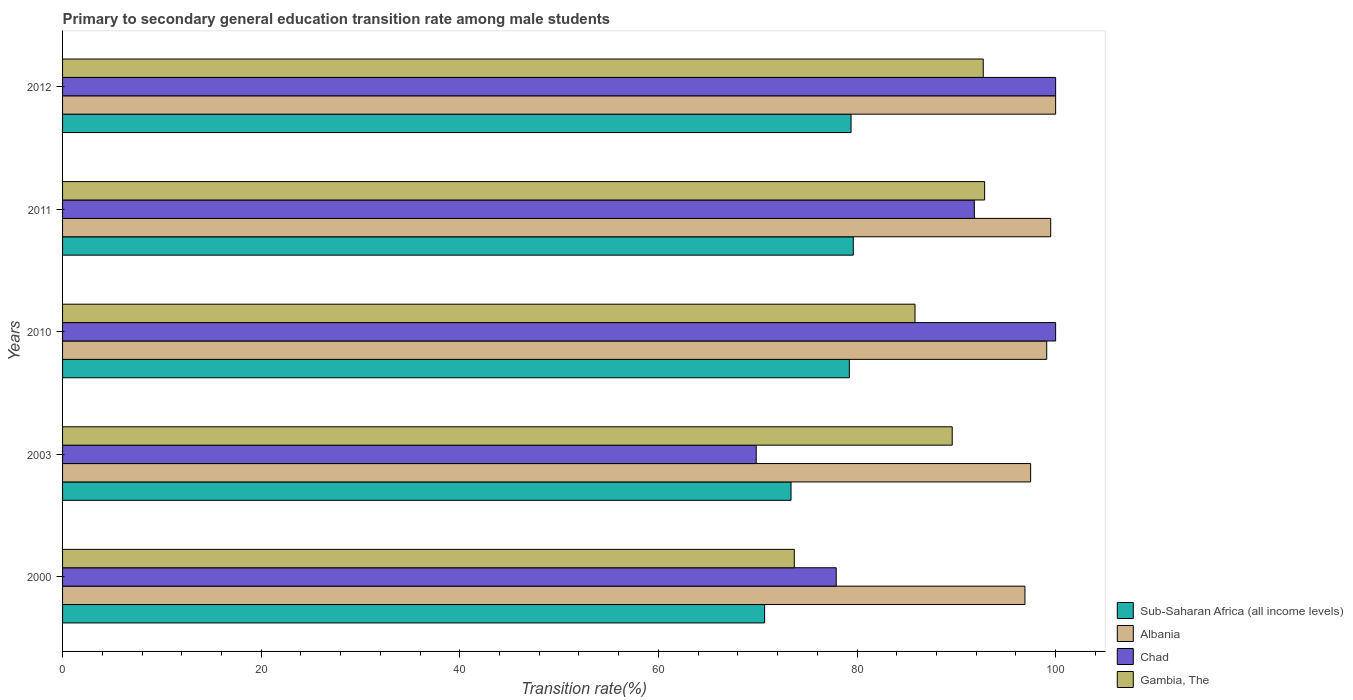Are the number of bars per tick equal to the number of legend labels?
Your answer should be very brief. Yes. How many bars are there on the 3rd tick from the top?
Offer a terse response. 4. In how many cases, is the number of bars for a given year not equal to the number of legend labels?
Offer a terse response. 0. What is the transition rate in Sub-Saharan Africa (all income levels) in 2012?
Offer a very short reply. 79.4. Across all years, what is the maximum transition rate in Gambia, The?
Provide a succinct answer. 92.85. Across all years, what is the minimum transition rate in Albania?
Your response must be concise. 96.91. In which year was the transition rate in Albania maximum?
Make the answer very short. 2012. In which year was the transition rate in Albania minimum?
Keep it short and to the point. 2000. What is the total transition rate in Sub-Saharan Africa (all income levels) in the graph?
Offer a terse response. 382.31. What is the difference between the transition rate in Chad in 2003 and that in 2012?
Offer a terse response. -30.15. What is the difference between the transition rate in Albania in 2000 and the transition rate in Sub-Saharan Africa (all income levels) in 2012?
Provide a succinct answer. 17.51. What is the average transition rate in Albania per year?
Your answer should be compact. 98.6. In the year 2003, what is the difference between the transition rate in Sub-Saharan Africa (all income levels) and transition rate in Albania?
Provide a succinct answer. -24.13. What is the ratio of the transition rate in Albania in 2011 to that in 2012?
Ensure brevity in your answer.  1. What is the difference between the highest and the lowest transition rate in Chad?
Ensure brevity in your answer.  30.15. In how many years, is the transition rate in Gambia, The greater than the average transition rate in Gambia, The taken over all years?
Keep it short and to the point. 3. Is the sum of the transition rate in Albania in 2003 and 2012 greater than the maximum transition rate in Chad across all years?
Your response must be concise. Yes. Is it the case that in every year, the sum of the transition rate in Gambia, The and transition rate in Chad is greater than the sum of transition rate in Sub-Saharan Africa (all income levels) and transition rate in Albania?
Your response must be concise. No. What does the 2nd bar from the top in 2000 represents?
Make the answer very short. Chad. What does the 3rd bar from the bottom in 2003 represents?
Your answer should be very brief. Chad. How many years are there in the graph?
Give a very brief answer. 5. Where does the legend appear in the graph?
Give a very brief answer. Bottom right. What is the title of the graph?
Offer a terse response. Primary to secondary general education transition rate among male students. Does "Moldova" appear as one of the legend labels in the graph?
Provide a short and direct response. No. What is the label or title of the X-axis?
Give a very brief answer. Transition rate(%). What is the label or title of the Y-axis?
Your response must be concise. Years. What is the Transition rate(%) of Sub-Saharan Africa (all income levels) in 2000?
Ensure brevity in your answer.  70.7. What is the Transition rate(%) of Albania in 2000?
Your response must be concise. 96.91. What is the Transition rate(%) of Chad in 2000?
Your response must be concise. 77.91. What is the Transition rate(%) of Gambia, The in 2000?
Your answer should be very brief. 73.69. What is the Transition rate(%) of Sub-Saharan Africa (all income levels) in 2003?
Your response must be concise. 73.36. What is the Transition rate(%) in Albania in 2003?
Make the answer very short. 97.48. What is the Transition rate(%) of Chad in 2003?
Ensure brevity in your answer.  69.85. What is the Transition rate(%) of Gambia, The in 2003?
Offer a very short reply. 89.59. What is the Transition rate(%) of Sub-Saharan Africa (all income levels) in 2010?
Offer a very short reply. 79.23. What is the Transition rate(%) of Albania in 2010?
Offer a terse response. 99.1. What is the Transition rate(%) in Chad in 2010?
Make the answer very short. 100. What is the Transition rate(%) in Gambia, The in 2010?
Your answer should be compact. 85.84. What is the Transition rate(%) of Sub-Saharan Africa (all income levels) in 2011?
Provide a succinct answer. 79.62. What is the Transition rate(%) in Albania in 2011?
Ensure brevity in your answer.  99.5. What is the Transition rate(%) of Chad in 2011?
Give a very brief answer. 91.82. What is the Transition rate(%) in Gambia, The in 2011?
Your response must be concise. 92.85. What is the Transition rate(%) in Sub-Saharan Africa (all income levels) in 2012?
Keep it short and to the point. 79.4. What is the Transition rate(%) in Gambia, The in 2012?
Offer a very short reply. 92.71. Across all years, what is the maximum Transition rate(%) of Sub-Saharan Africa (all income levels)?
Ensure brevity in your answer.  79.62. Across all years, what is the maximum Transition rate(%) of Gambia, The?
Your answer should be very brief. 92.85. Across all years, what is the minimum Transition rate(%) of Sub-Saharan Africa (all income levels)?
Make the answer very short. 70.7. Across all years, what is the minimum Transition rate(%) in Albania?
Ensure brevity in your answer.  96.91. Across all years, what is the minimum Transition rate(%) in Chad?
Offer a terse response. 69.85. Across all years, what is the minimum Transition rate(%) in Gambia, The?
Offer a very short reply. 73.69. What is the total Transition rate(%) in Sub-Saharan Africa (all income levels) in the graph?
Give a very brief answer. 382.31. What is the total Transition rate(%) in Albania in the graph?
Offer a terse response. 493. What is the total Transition rate(%) of Chad in the graph?
Provide a short and direct response. 439.57. What is the total Transition rate(%) of Gambia, The in the graph?
Give a very brief answer. 434.68. What is the difference between the Transition rate(%) of Sub-Saharan Africa (all income levels) in 2000 and that in 2003?
Provide a short and direct response. -2.66. What is the difference between the Transition rate(%) of Albania in 2000 and that in 2003?
Provide a short and direct response. -0.57. What is the difference between the Transition rate(%) in Chad in 2000 and that in 2003?
Offer a terse response. 8.06. What is the difference between the Transition rate(%) of Gambia, The in 2000 and that in 2003?
Make the answer very short. -15.9. What is the difference between the Transition rate(%) of Sub-Saharan Africa (all income levels) in 2000 and that in 2010?
Provide a short and direct response. -8.53. What is the difference between the Transition rate(%) of Albania in 2000 and that in 2010?
Offer a terse response. -2.19. What is the difference between the Transition rate(%) of Chad in 2000 and that in 2010?
Your response must be concise. -22.09. What is the difference between the Transition rate(%) in Gambia, The in 2000 and that in 2010?
Ensure brevity in your answer.  -12.15. What is the difference between the Transition rate(%) in Sub-Saharan Africa (all income levels) in 2000 and that in 2011?
Your answer should be very brief. -8.93. What is the difference between the Transition rate(%) of Albania in 2000 and that in 2011?
Ensure brevity in your answer.  -2.6. What is the difference between the Transition rate(%) in Chad in 2000 and that in 2011?
Keep it short and to the point. -13.91. What is the difference between the Transition rate(%) in Gambia, The in 2000 and that in 2011?
Provide a short and direct response. -19.17. What is the difference between the Transition rate(%) in Sub-Saharan Africa (all income levels) in 2000 and that in 2012?
Your answer should be compact. -8.7. What is the difference between the Transition rate(%) in Albania in 2000 and that in 2012?
Your answer should be very brief. -3.09. What is the difference between the Transition rate(%) of Chad in 2000 and that in 2012?
Give a very brief answer. -22.09. What is the difference between the Transition rate(%) in Gambia, The in 2000 and that in 2012?
Your answer should be compact. -19.03. What is the difference between the Transition rate(%) of Sub-Saharan Africa (all income levels) in 2003 and that in 2010?
Offer a terse response. -5.87. What is the difference between the Transition rate(%) in Albania in 2003 and that in 2010?
Keep it short and to the point. -1.62. What is the difference between the Transition rate(%) in Chad in 2003 and that in 2010?
Provide a short and direct response. -30.15. What is the difference between the Transition rate(%) in Gambia, The in 2003 and that in 2010?
Your answer should be compact. 3.75. What is the difference between the Transition rate(%) in Sub-Saharan Africa (all income levels) in 2003 and that in 2011?
Provide a short and direct response. -6.27. What is the difference between the Transition rate(%) in Albania in 2003 and that in 2011?
Provide a short and direct response. -2.02. What is the difference between the Transition rate(%) in Chad in 2003 and that in 2011?
Offer a very short reply. -21.97. What is the difference between the Transition rate(%) of Gambia, The in 2003 and that in 2011?
Make the answer very short. -3.26. What is the difference between the Transition rate(%) in Sub-Saharan Africa (all income levels) in 2003 and that in 2012?
Offer a terse response. -6.04. What is the difference between the Transition rate(%) of Albania in 2003 and that in 2012?
Give a very brief answer. -2.52. What is the difference between the Transition rate(%) in Chad in 2003 and that in 2012?
Ensure brevity in your answer.  -30.15. What is the difference between the Transition rate(%) in Gambia, The in 2003 and that in 2012?
Offer a terse response. -3.12. What is the difference between the Transition rate(%) in Sub-Saharan Africa (all income levels) in 2010 and that in 2011?
Provide a short and direct response. -0.39. What is the difference between the Transition rate(%) of Albania in 2010 and that in 2011?
Your response must be concise. -0.4. What is the difference between the Transition rate(%) in Chad in 2010 and that in 2011?
Offer a terse response. 8.18. What is the difference between the Transition rate(%) of Gambia, The in 2010 and that in 2011?
Your answer should be compact. -7.01. What is the difference between the Transition rate(%) in Sub-Saharan Africa (all income levels) in 2010 and that in 2012?
Ensure brevity in your answer.  -0.17. What is the difference between the Transition rate(%) of Albania in 2010 and that in 2012?
Give a very brief answer. -0.9. What is the difference between the Transition rate(%) of Chad in 2010 and that in 2012?
Your response must be concise. 0. What is the difference between the Transition rate(%) in Gambia, The in 2010 and that in 2012?
Ensure brevity in your answer.  -6.87. What is the difference between the Transition rate(%) of Sub-Saharan Africa (all income levels) in 2011 and that in 2012?
Make the answer very short. 0.23. What is the difference between the Transition rate(%) of Albania in 2011 and that in 2012?
Ensure brevity in your answer.  -0.5. What is the difference between the Transition rate(%) in Chad in 2011 and that in 2012?
Give a very brief answer. -8.18. What is the difference between the Transition rate(%) in Gambia, The in 2011 and that in 2012?
Offer a terse response. 0.14. What is the difference between the Transition rate(%) of Sub-Saharan Africa (all income levels) in 2000 and the Transition rate(%) of Albania in 2003?
Provide a short and direct response. -26.79. What is the difference between the Transition rate(%) of Sub-Saharan Africa (all income levels) in 2000 and the Transition rate(%) of Chad in 2003?
Your answer should be compact. 0.85. What is the difference between the Transition rate(%) of Sub-Saharan Africa (all income levels) in 2000 and the Transition rate(%) of Gambia, The in 2003?
Offer a terse response. -18.89. What is the difference between the Transition rate(%) in Albania in 2000 and the Transition rate(%) in Chad in 2003?
Keep it short and to the point. 27.06. What is the difference between the Transition rate(%) of Albania in 2000 and the Transition rate(%) of Gambia, The in 2003?
Provide a succinct answer. 7.32. What is the difference between the Transition rate(%) of Chad in 2000 and the Transition rate(%) of Gambia, The in 2003?
Ensure brevity in your answer.  -11.68. What is the difference between the Transition rate(%) of Sub-Saharan Africa (all income levels) in 2000 and the Transition rate(%) of Albania in 2010?
Offer a very short reply. -28.41. What is the difference between the Transition rate(%) of Sub-Saharan Africa (all income levels) in 2000 and the Transition rate(%) of Chad in 2010?
Your response must be concise. -29.3. What is the difference between the Transition rate(%) in Sub-Saharan Africa (all income levels) in 2000 and the Transition rate(%) in Gambia, The in 2010?
Your answer should be compact. -15.14. What is the difference between the Transition rate(%) of Albania in 2000 and the Transition rate(%) of Chad in 2010?
Your answer should be very brief. -3.09. What is the difference between the Transition rate(%) in Albania in 2000 and the Transition rate(%) in Gambia, The in 2010?
Ensure brevity in your answer.  11.07. What is the difference between the Transition rate(%) in Chad in 2000 and the Transition rate(%) in Gambia, The in 2010?
Keep it short and to the point. -7.94. What is the difference between the Transition rate(%) in Sub-Saharan Africa (all income levels) in 2000 and the Transition rate(%) in Albania in 2011?
Provide a succinct answer. -28.81. What is the difference between the Transition rate(%) of Sub-Saharan Africa (all income levels) in 2000 and the Transition rate(%) of Chad in 2011?
Your answer should be very brief. -21.12. What is the difference between the Transition rate(%) in Sub-Saharan Africa (all income levels) in 2000 and the Transition rate(%) in Gambia, The in 2011?
Ensure brevity in your answer.  -22.16. What is the difference between the Transition rate(%) in Albania in 2000 and the Transition rate(%) in Chad in 2011?
Your answer should be very brief. 5.09. What is the difference between the Transition rate(%) of Albania in 2000 and the Transition rate(%) of Gambia, The in 2011?
Offer a terse response. 4.06. What is the difference between the Transition rate(%) of Chad in 2000 and the Transition rate(%) of Gambia, The in 2011?
Offer a very short reply. -14.95. What is the difference between the Transition rate(%) of Sub-Saharan Africa (all income levels) in 2000 and the Transition rate(%) of Albania in 2012?
Offer a terse response. -29.3. What is the difference between the Transition rate(%) in Sub-Saharan Africa (all income levels) in 2000 and the Transition rate(%) in Chad in 2012?
Offer a terse response. -29.3. What is the difference between the Transition rate(%) of Sub-Saharan Africa (all income levels) in 2000 and the Transition rate(%) of Gambia, The in 2012?
Ensure brevity in your answer.  -22.02. What is the difference between the Transition rate(%) of Albania in 2000 and the Transition rate(%) of Chad in 2012?
Offer a very short reply. -3.09. What is the difference between the Transition rate(%) of Albania in 2000 and the Transition rate(%) of Gambia, The in 2012?
Your response must be concise. 4.2. What is the difference between the Transition rate(%) in Chad in 2000 and the Transition rate(%) in Gambia, The in 2012?
Ensure brevity in your answer.  -14.81. What is the difference between the Transition rate(%) in Sub-Saharan Africa (all income levels) in 2003 and the Transition rate(%) in Albania in 2010?
Provide a short and direct response. -25.75. What is the difference between the Transition rate(%) in Sub-Saharan Africa (all income levels) in 2003 and the Transition rate(%) in Chad in 2010?
Your answer should be very brief. -26.64. What is the difference between the Transition rate(%) of Sub-Saharan Africa (all income levels) in 2003 and the Transition rate(%) of Gambia, The in 2010?
Ensure brevity in your answer.  -12.49. What is the difference between the Transition rate(%) of Albania in 2003 and the Transition rate(%) of Chad in 2010?
Your answer should be very brief. -2.52. What is the difference between the Transition rate(%) in Albania in 2003 and the Transition rate(%) in Gambia, The in 2010?
Make the answer very short. 11.64. What is the difference between the Transition rate(%) of Chad in 2003 and the Transition rate(%) of Gambia, The in 2010?
Give a very brief answer. -15.99. What is the difference between the Transition rate(%) of Sub-Saharan Africa (all income levels) in 2003 and the Transition rate(%) of Albania in 2011?
Offer a terse response. -26.15. What is the difference between the Transition rate(%) in Sub-Saharan Africa (all income levels) in 2003 and the Transition rate(%) in Chad in 2011?
Provide a short and direct response. -18.46. What is the difference between the Transition rate(%) of Sub-Saharan Africa (all income levels) in 2003 and the Transition rate(%) of Gambia, The in 2011?
Make the answer very short. -19.5. What is the difference between the Transition rate(%) in Albania in 2003 and the Transition rate(%) in Chad in 2011?
Provide a short and direct response. 5.67. What is the difference between the Transition rate(%) of Albania in 2003 and the Transition rate(%) of Gambia, The in 2011?
Your response must be concise. 4.63. What is the difference between the Transition rate(%) in Chad in 2003 and the Transition rate(%) in Gambia, The in 2011?
Offer a very short reply. -23. What is the difference between the Transition rate(%) of Sub-Saharan Africa (all income levels) in 2003 and the Transition rate(%) of Albania in 2012?
Your response must be concise. -26.64. What is the difference between the Transition rate(%) of Sub-Saharan Africa (all income levels) in 2003 and the Transition rate(%) of Chad in 2012?
Give a very brief answer. -26.64. What is the difference between the Transition rate(%) of Sub-Saharan Africa (all income levels) in 2003 and the Transition rate(%) of Gambia, The in 2012?
Offer a terse response. -19.36. What is the difference between the Transition rate(%) of Albania in 2003 and the Transition rate(%) of Chad in 2012?
Your answer should be compact. -2.52. What is the difference between the Transition rate(%) in Albania in 2003 and the Transition rate(%) in Gambia, The in 2012?
Offer a terse response. 4.77. What is the difference between the Transition rate(%) in Chad in 2003 and the Transition rate(%) in Gambia, The in 2012?
Give a very brief answer. -22.86. What is the difference between the Transition rate(%) of Sub-Saharan Africa (all income levels) in 2010 and the Transition rate(%) of Albania in 2011?
Your answer should be compact. -20.27. What is the difference between the Transition rate(%) in Sub-Saharan Africa (all income levels) in 2010 and the Transition rate(%) in Chad in 2011?
Provide a succinct answer. -12.59. What is the difference between the Transition rate(%) of Sub-Saharan Africa (all income levels) in 2010 and the Transition rate(%) of Gambia, The in 2011?
Ensure brevity in your answer.  -13.62. What is the difference between the Transition rate(%) in Albania in 2010 and the Transition rate(%) in Chad in 2011?
Keep it short and to the point. 7.29. What is the difference between the Transition rate(%) in Albania in 2010 and the Transition rate(%) in Gambia, The in 2011?
Provide a short and direct response. 6.25. What is the difference between the Transition rate(%) in Chad in 2010 and the Transition rate(%) in Gambia, The in 2011?
Your answer should be compact. 7.15. What is the difference between the Transition rate(%) of Sub-Saharan Africa (all income levels) in 2010 and the Transition rate(%) of Albania in 2012?
Provide a short and direct response. -20.77. What is the difference between the Transition rate(%) of Sub-Saharan Africa (all income levels) in 2010 and the Transition rate(%) of Chad in 2012?
Ensure brevity in your answer.  -20.77. What is the difference between the Transition rate(%) of Sub-Saharan Africa (all income levels) in 2010 and the Transition rate(%) of Gambia, The in 2012?
Offer a very short reply. -13.48. What is the difference between the Transition rate(%) of Albania in 2010 and the Transition rate(%) of Chad in 2012?
Your answer should be very brief. -0.9. What is the difference between the Transition rate(%) in Albania in 2010 and the Transition rate(%) in Gambia, The in 2012?
Ensure brevity in your answer.  6.39. What is the difference between the Transition rate(%) in Chad in 2010 and the Transition rate(%) in Gambia, The in 2012?
Keep it short and to the point. 7.29. What is the difference between the Transition rate(%) of Sub-Saharan Africa (all income levels) in 2011 and the Transition rate(%) of Albania in 2012?
Keep it short and to the point. -20.38. What is the difference between the Transition rate(%) in Sub-Saharan Africa (all income levels) in 2011 and the Transition rate(%) in Chad in 2012?
Your answer should be very brief. -20.38. What is the difference between the Transition rate(%) in Sub-Saharan Africa (all income levels) in 2011 and the Transition rate(%) in Gambia, The in 2012?
Keep it short and to the point. -13.09. What is the difference between the Transition rate(%) of Albania in 2011 and the Transition rate(%) of Chad in 2012?
Provide a short and direct response. -0.5. What is the difference between the Transition rate(%) of Albania in 2011 and the Transition rate(%) of Gambia, The in 2012?
Make the answer very short. 6.79. What is the difference between the Transition rate(%) of Chad in 2011 and the Transition rate(%) of Gambia, The in 2012?
Provide a succinct answer. -0.9. What is the average Transition rate(%) of Sub-Saharan Africa (all income levels) per year?
Ensure brevity in your answer.  76.46. What is the average Transition rate(%) of Albania per year?
Keep it short and to the point. 98.6. What is the average Transition rate(%) of Chad per year?
Ensure brevity in your answer.  87.91. What is the average Transition rate(%) of Gambia, The per year?
Your response must be concise. 86.94. In the year 2000, what is the difference between the Transition rate(%) of Sub-Saharan Africa (all income levels) and Transition rate(%) of Albania?
Offer a very short reply. -26.21. In the year 2000, what is the difference between the Transition rate(%) of Sub-Saharan Africa (all income levels) and Transition rate(%) of Chad?
Give a very brief answer. -7.21. In the year 2000, what is the difference between the Transition rate(%) in Sub-Saharan Africa (all income levels) and Transition rate(%) in Gambia, The?
Provide a short and direct response. -2.99. In the year 2000, what is the difference between the Transition rate(%) in Albania and Transition rate(%) in Chad?
Your response must be concise. 19. In the year 2000, what is the difference between the Transition rate(%) of Albania and Transition rate(%) of Gambia, The?
Your answer should be compact. 23.22. In the year 2000, what is the difference between the Transition rate(%) in Chad and Transition rate(%) in Gambia, The?
Your response must be concise. 4.22. In the year 2003, what is the difference between the Transition rate(%) of Sub-Saharan Africa (all income levels) and Transition rate(%) of Albania?
Provide a succinct answer. -24.13. In the year 2003, what is the difference between the Transition rate(%) of Sub-Saharan Africa (all income levels) and Transition rate(%) of Chad?
Your answer should be compact. 3.51. In the year 2003, what is the difference between the Transition rate(%) in Sub-Saharan Africa (all income levels) and Transition rate(%) in Gambia, The?
Keep it short and to the point. -16.23. In the year 2003, what is the difference between the Transition rate(%) of Albania and Transition rate(%) of Chad?
Make the answer very short. 27.63. In the year 2003, what is the difference between the Transition rate(%) in Albania and Transition rate(%) in Gambia, The?
Offer a very short reply. 7.89. In the year 2003, what is the difference between the Transition rate(%) in Chad and Transition rate(%) in Gambia, The?
Your answer should be compact. -19.74. In the year 2010, what is the difference between the Transition rate(%) of Sub-Saharan Africa (all income levels) and Transition rate(%) of Albania?
Offer a very short reply. -19.87. In the year 2010, what is the difference between the Transition rate(%) in Sub-Saharan Africa (all income levels) and Transition rate(%) in Chad?
Provide a succinct answer. -20.77. In the year 2010, what is the difference between the Transition rate(%) in Sub-Saharan Africa (all income levels) and Transition rate(%) in Gambia, The?
Keep it short and to the point. -6.61. In the year 2010, what is the difference between the Transition rate(%) in Albania and Transition rate(%) in Chad?
Make the answer very short. -0.9. In the year 2010, what is the difference between the Transition rate(%) in Albania and Transition rate(%) in Gambia, The?
Provide a succinct answer. 13.26. In the year 2010, what is the difference between the Transition rate(%) of Chad and Transition rate(%) of Gambia, The?
Your answer should be compact. 14.16. In the year 2011, what is the difference between the Transition rate(%) in Sub-Saharan Africa (all income levels) and Transition rate(%) in Albania?
Give a very brief answer. -19.88. In the year 2011, what is the difference between the Transition rate(%) of Sub-Saharan Africa (all income levels) and Transition rate(%) of Chad?
Your answer should be compact. -12.19. In the year 2011, what is the difference between the Transition rate(%) of Sub-Saharan Africa (all income levels) and Transition rate(%) of Gambia, The?
Your answer should be compact. -13.23. In the year 2011, what is the difference between the Transition rate(%) in Albania and Transition rate(%) in Chad?
Provide a short and direct response. 7.69. In the year 2011, what is the difference between the Transition rate(%) of Albania and Transition rate(%) of Gambia, The?
Make the answer very short. 6.65. In the year 2011, what is the difference between the Transition rate(%) of Chad and Transition rate(%) of Gambia, The?
Make the answer very short. -1.04. In the year 2012, what is the difference between the Transition rate(%) of Sub-Saharan Africa (all income levels) and Transition rate(%) of Albania?
Your answer should be compact. -20.6. In the year 2012, what is the difference between the Transition rate(%) in Sub-Saharan Africa (all income levels) and Transition rate(%) in Chad?
Your answer should be very brief. -20.6. In the year 2012, what is the difference between the Transition rate(%) in Sub-Saharan Africa (all income levels) and Transition rate(%) in Gambia, The?
Your answer should be compact. -13.31. In the year 2012, what is the difference between the Transition rate(%) of Albania and Transition rate(%) of Gambia, The?
Offer a very short reply. 7.29. In the year 2012, what is the difference between the Transition rate(%) in Chad and Transition rate(%) in Gambia, The?
Ensure brevity in your answer.  7.29. What is the ratio of the Transition rate(%) of Sub-Saharan Africa (all income levels) in 2000 to that in 2003?
Your response must be concise. 0.96. What is the ratio of the Transition rate(%) of Chad in 2000 to that in 2003?
Provide a short and direct response. 1.12. What is the ratio of the Transition rate(%) in Gambia, The in 2000 to that in 2003?
Your response must be concise. 0.82. What is the ratio of the Transition rate(%) of Sub-Saharan Africa (all income levels) in 2000 to that in 2010?
Provide a succinct answer. 0.89. What is the ratio of the Transition rate(%) of Albania in 2000 to that in 2010?
Provide a short and direct response. 0.98. What is the ratio of the Transition rate(%) of Chad in 2000 to that in 2010?
Keep it short and to the point. 0.78. What is the ratio of the Transition rate(%) in Gambia, The in 2000 to that in 2010?
Your response must be concise. 0.86. What is the ratio of the Transition rate(%) of Sub-Saharan Africa (all income levels) in 2000 to that in 2011?
Offer a terse response. 0.89. What is the ratio of the Transition rate(%) in Albania in 2000 to that in 2011?
Ensure brevity in your answer.  0.97. What is the ratio of the Transition rate(%) in Chad in 2000 to that in 2011?
Make the answer very short. 0.85. What is the ratio of the Transition rate(%) of Gambia, The in 2000 to that in 2011?
Your answer should be very brief. 0.79. What is the ratio of the Transition rate(%) of Sub-Saharan Africa (all income levels) in 2000 to that in 2012?
Make the answer very short. 0.89. What is the ratio of the Transition rate(%) in Albania in 2000 to that in 2012?
Make the answer very short. 0.97. What is the ratio of the Transition rate(%) of Chad in 2000 to that in 2012?
Make the answer very short. 0.78. What is the ratio of the Transition rate(%) in Gambia, The in 2000 to that in 2012?
Offer a very short reply. 0.79. What is the ratio of the Transition rate(%) in Sub-Saharan Africa (all income levels) in 2003 to that in 2010?
Offer a terse response. 0.93. What is the ratio of the Transition rate(%) in Albania in 2003 to that in 2010?
Your response must be concise. 0.98. What is the ratio of the Transition rate(%) of Chad in 2003 to that in 2010?
Make the answer very short. 0.7. What is the ratio of the Transition rate(%) in Gambia, The in 2003 to that in 2010?
Keep it short and to the point. 1.04. What is the ratio of the Transition rate(%) in Sub-Saharan Africa (all income levels) in 2003 to that in 2011?
Offer a terse response. 0.92. What is the ratio of the Transition rate(%) in Albania in 2003 to that in 2011?
Your answer should be very brief. 0.98. What is the ratio of the Transition rate(%) in Chad in 2003 to that in 2011?
Provide a short and direct response. 0.76. What is the ratio of the Transition rate(%) in Gambia, The in 2003 to that in 2011?
Give a very brief answer. 0.96. What is the ratio of the Transition rate(%) in Sub-Saharan Africa (all income levels) in 2003 to that in 2012?
Provide a short and direct response. 0.92. What is the ratio of the Transition rate(%) in Albania in 2003 to that in 2012?
Make the answer very short. 0.97. What is the ratio of the Transition rate(%) of Chad in 2003 to that in 2012?
Offer a terse response. 0.7. What is the ratio of the Transition rate(%) in Gambia, The in 2003 to that in 2012?
Provide a succinct answer. 0.97. What is the ratio of the Transition rate(%) in Albania in 2010 to that in 2011?
Give a very brief answer. 1. What is the ratio of the Transition rate(%) in Chad in 2010 to that in 2011?
Provide a short and direct response. 1.09. What is the ratio of the Transition rate(%) of Gambia, The in 2010 to that in 2011?
Make the answer very short. 0.92. What is the ratio of the Transition rate(%) of Gambia, The in 2010 to that in 2012?
Your answer should be compact. 0.93. What is the ratio of the Transition rate(%) in Sub-Saharan Africa (all income levels) in 2011 to that in 2012?
Keep it short and to the point. 1. What is the ratio of the Transition rate(%) of Chad in 2011 to that in 2012?
Offer a very short reply. 0.92. What is the difference between the highest and the second highest Transition rate(%) in Sub-Saharan Africa (all income levels)?
Give a very brief answer. 0.23. What is the difference between the highest and the second highest Transition rate(%) of Albania?
Give a very brief answer. 0.5. What is the difference between the highest and the second highest Transition rate(%) in Chad?
Provide a short and direct response. 0. What is the difference between the highest and the second highest Transition rate(%) of Gambia, The?
Offer a terse response. 0.14. What is the difference between the highest and the lowest Transition rate(%) of Sub-Saharan Africa (all income levels)?
Your response must be concise. 8.93. What is the difference between the highest and the lowest Transition rate(%) in Albania?
Your answer should be compact. 3.09. What is the difference between the highest and the lowest Transition rate(%) in Chad?
Your answer should be compact. 30.15. What is the difference between the highest and the lowest Transition rate(%) in Gambia, The?
Ensure brevity in your answer.  19.17. 